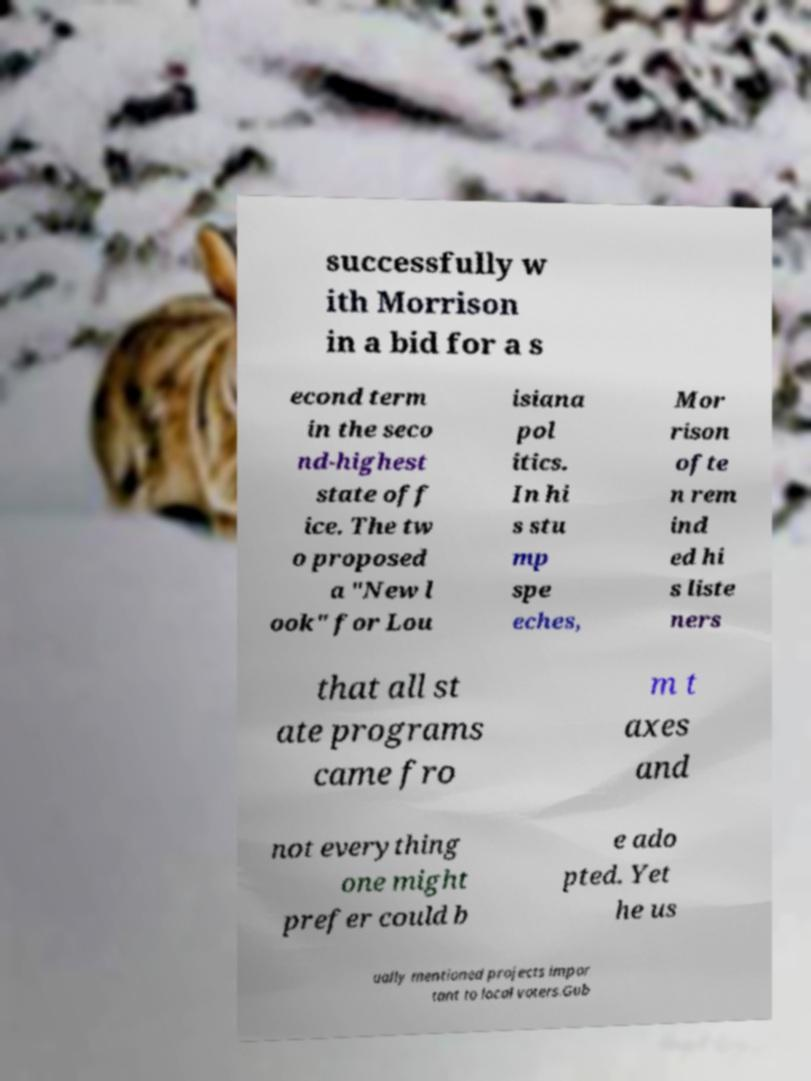Could you assist in decoding the text presented in this image and type it out clearly? successfully w ith Morrison in a bid for a s econd term in the seco nd-highest state off ice. The tw o proposed a "New l ook" for Lou isiana pol itics. In hi s stu mp spe eches, Mor rison ofte n rem ind ed hi s liste ners that all st ate programs came fro m t axes and not everything one might prefer could b e ado pted. Yet he us ually mentioned projects impor tant to local voters.Gub 